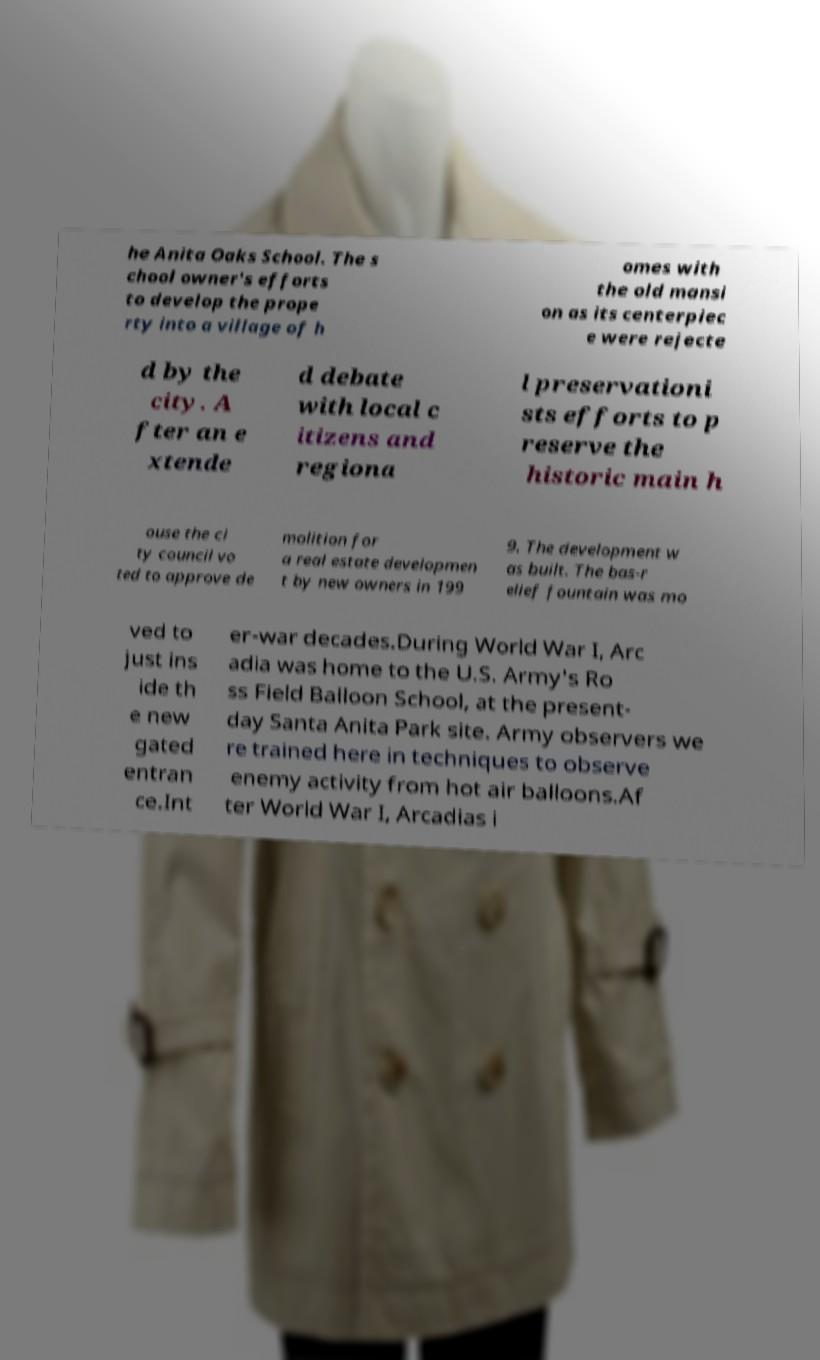Please read and relay the text visible in this image. What does it say? he Anita Oaks School. The s chool owner's efforts to develop the prope rty into a village of h omes with the old mansi on as its centerpiec e were rejecte d by the city. A fter an e xtende d debate with local c itizens and regiona l preservationi sts efforts to p reserve the historic main h ouse the ci ty council vo ted to approve de molition for a real estate developmen t by new owners in 199 9. The development w as built. The bas-r elief fountain was mo ved to just ins ide th e new gated entran ce.Int er-war decades.During World War I, Arc adia was home to the U.S. Army's Ro ss Field Balloon School, at the present- day Santa Anita Park site. Army observers we re trained here in techniques to observe enemy activity from hot air balloons.Af ter World War I, Arcadias i 